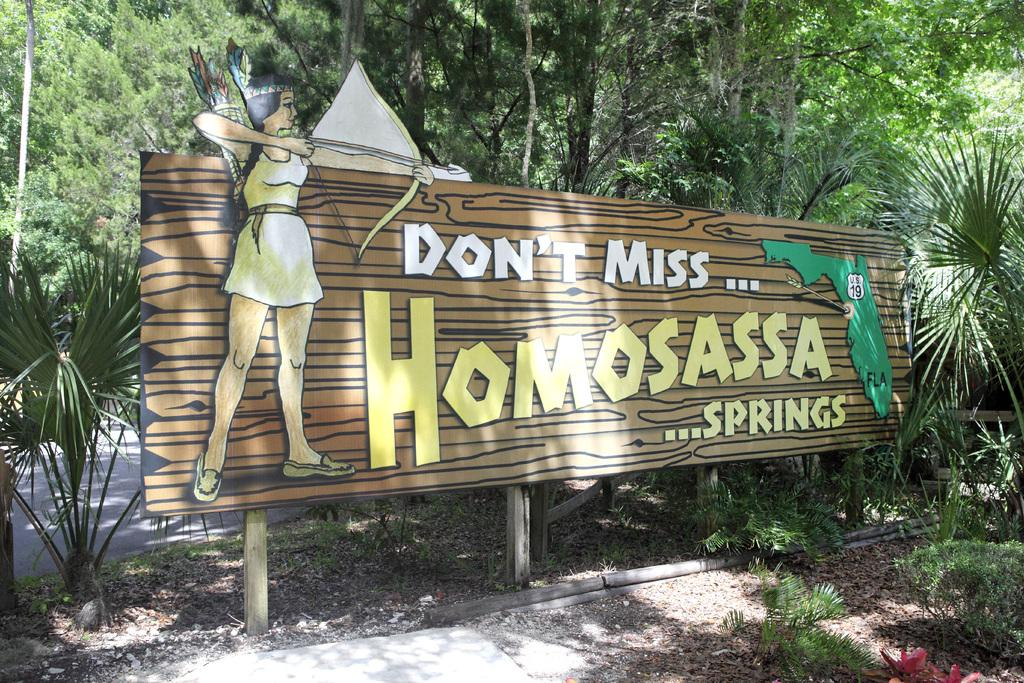What is the main object in the image? There is a board in the image. What is on the board? The board contains text and an image. What type of vegetation is visible in the image? There are plants and trees visible in the image. How many apples are hanging from the trees in the image? There are no apples visible in the image; only plants and trees can be seen. What advice does the person's uncle give in the image? There is no person or uncle present in the image, so it is not possible to determine any advice given. 